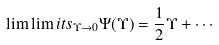<formula> <loc_0><loc_0><loc_500><loc_500>\lim \lim i t s _ { { \Upsilon } \to 0 } \Psi ( { \Upsilon } ) = \frac { 1 } { 2 } { \Upsilon } + \cdots</formula> 